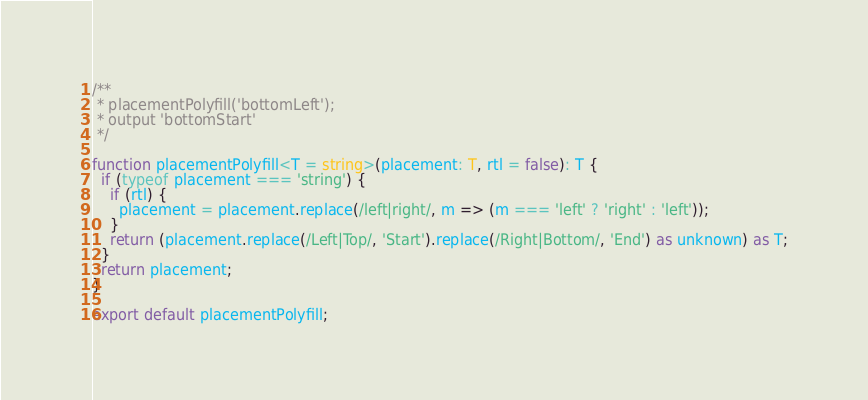Convert code to text. <code><loc_0><loc_0><loc_500><loc_500><_TypeScript_>/**
 * placementPolyfill('bottomLeft');
 * output 'bottomStart'
 */

function placementPolyfill<T = string>(placement: T, rtl = false): T {
  if (typeof placement === 'string') {
    if (rtl) {
      placement = placement.replace(/left|right/, m => (m === 'left' ? 'right' : 'left'));
    }
    return (placement.replace(/Left|Top/, 'Start').replace(/Right|Bottom/, 'End') as unknown) as T;
  }
  return placement;
}

export default placementPolyfill;
</code> 